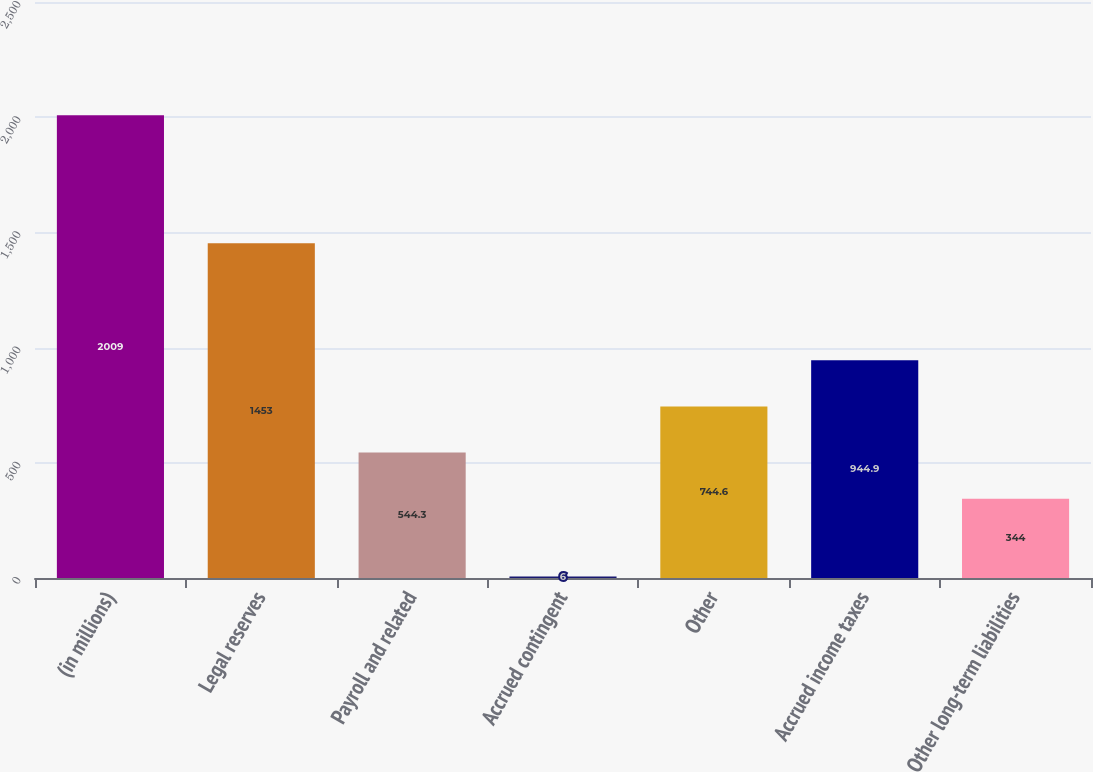<chart> <loc_0><loc_0><loc_500><loc_500><bar_chart><fcel>(in millions)<fcel>Legal reserves<fcel>Payroll and related<fcel>Accrued contingent<fcel>Other<fcel>Accrued income taxes<fcel>Other long-term liabilities<nl><fcel>2009<fcel>1453<fcel>544.3<fcel>6<fcel>744.6<fcel>944.9<fcel>344<nl></chart> 